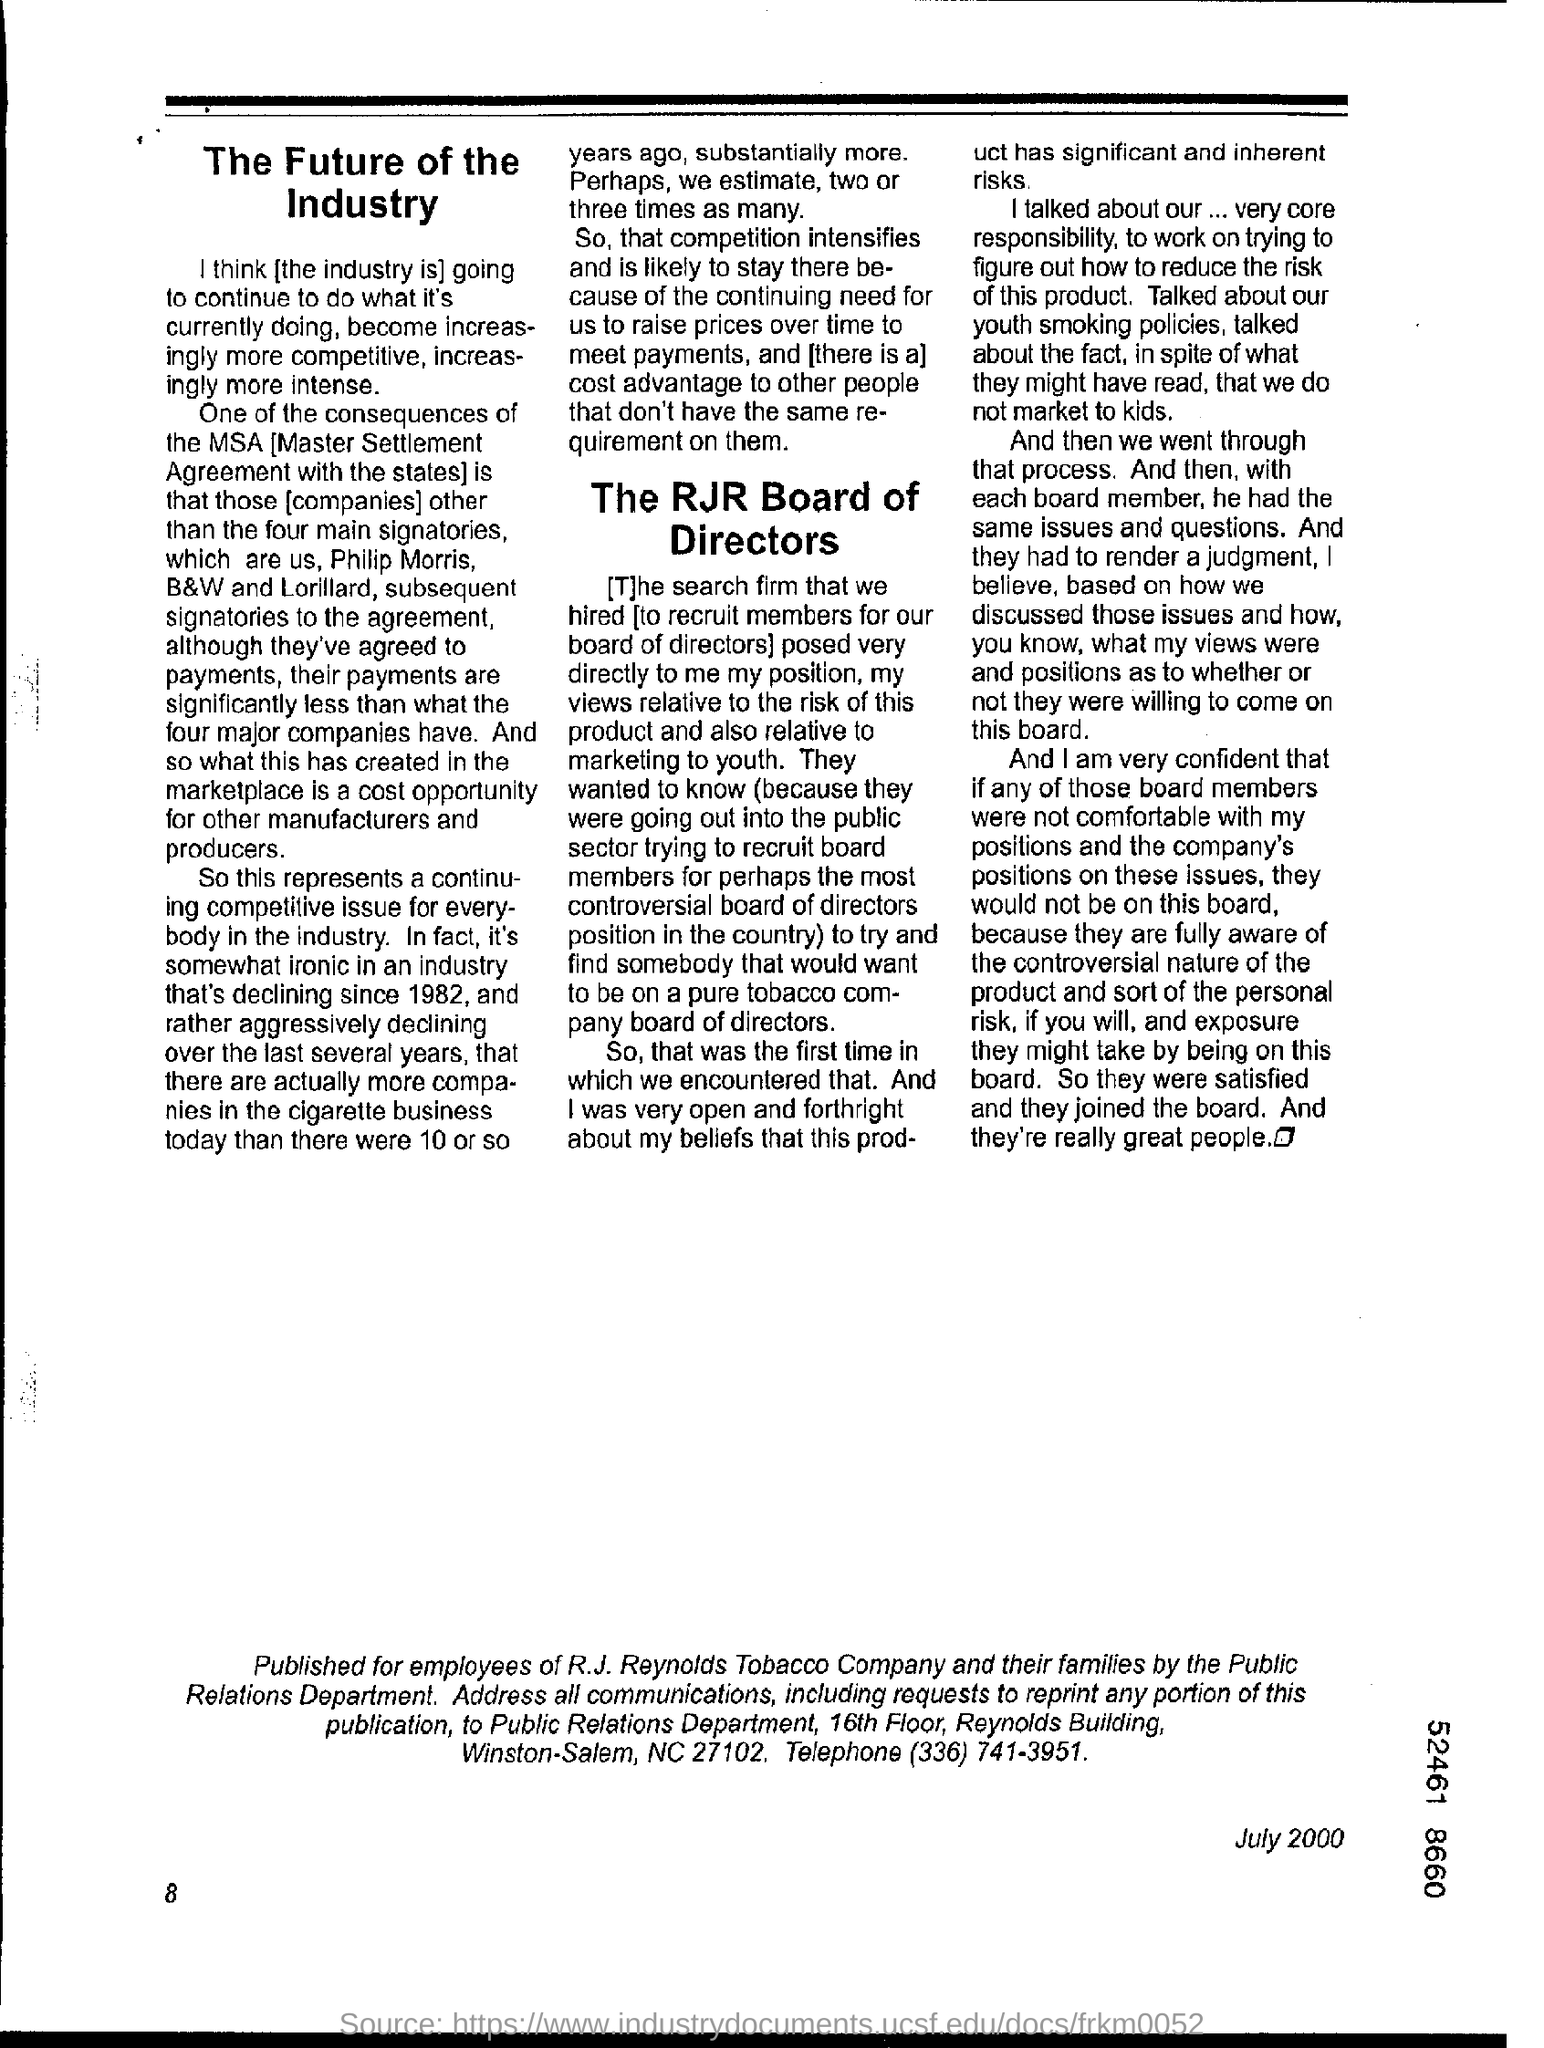What is the date mentioned in this document?
Keep it short and to the point. July 2000. What is the page no mentioned in this document?
Offer a very short reply. 8. 